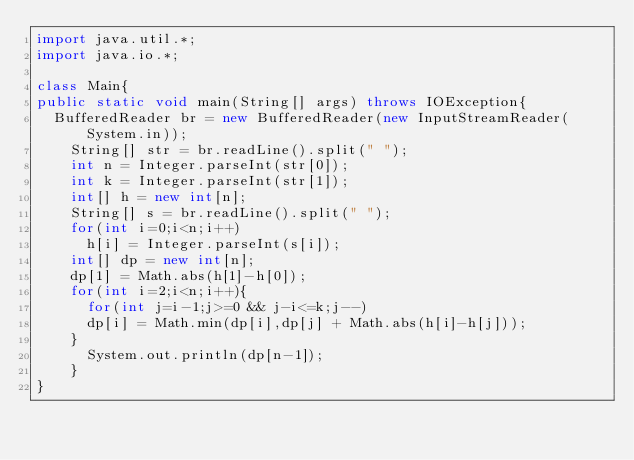Convert code to text. <code><loc_0><loc_0><loc_500><loc_500><_Java_>import java.util.*;
import java.io.*;
 
class Main{
public static void main(String[] args) throws IOException{
	BufferedReader br = new BufferedReader(new InputStreamReader(System.in));
  	String[] str = br.readLine().split(" ");
  	int n = Integer.parseInt(str[0]);
  	int k = Integer.parseInt(str[1]);
  	int[] h = new int[n];
  	String[] s = br.readLine().split(" ");
  	for(int i=0;i<n;i++)
      h[i] = Integer.parseInt(s[i]);
  	int[] dp = new int[n];
  	dp[1] = Math.abs(h[1]-h[0]);
  	for(int i=2;i<n;i++){
      for(int j=i-1;j>=0 && j-i<=k;j--)
      dp[i] = Math.min(dp[i],dp[j] + Math.abs(h[i]-h[j]));
    } 
      System.out.println(dp[n-1]);
    }
}</code> 